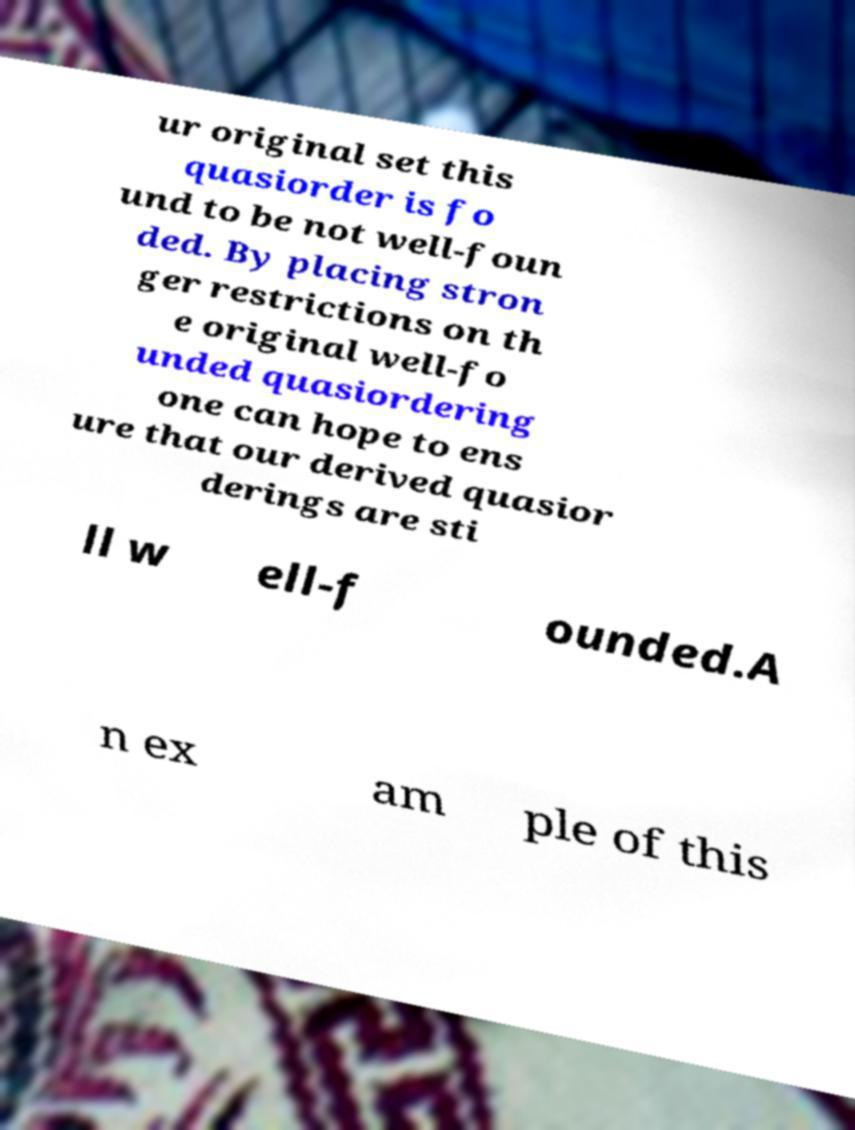Please read and relay the text visible in this image. What does it say? ur original set this quasiorder is fo und to be not well-foun ded. By placing stron ger restrictions on th e original well-fo unded quasiordering one can hope to ens ure that our derived quasior derings are sti ll w ell-f ounded.A n ex am ple of this 